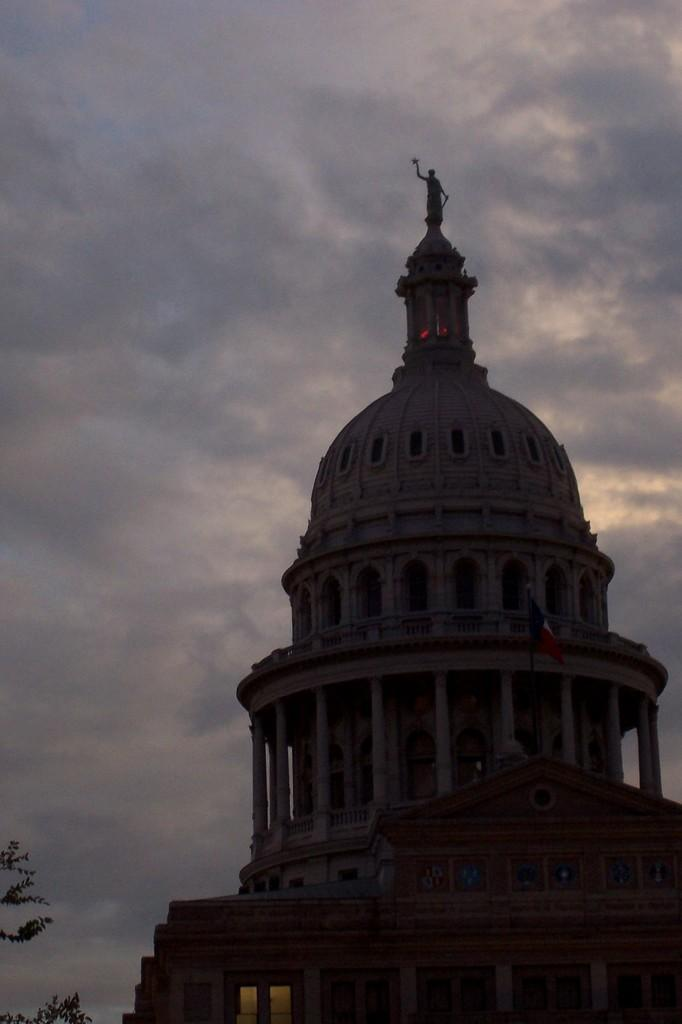What type of structure is visible in the image? There is a building in the image. Are there any natural elements present near the building? Yes, there is a tree on the side of the building. How would you describe the weather based on the image? The sky is cloudy in the image, which suggests a potentially overcast or cloudy day. What color is the smoke coming out of the chimney in the image? There is no chimney or smoke present in the image; it only features a building and a tree. 